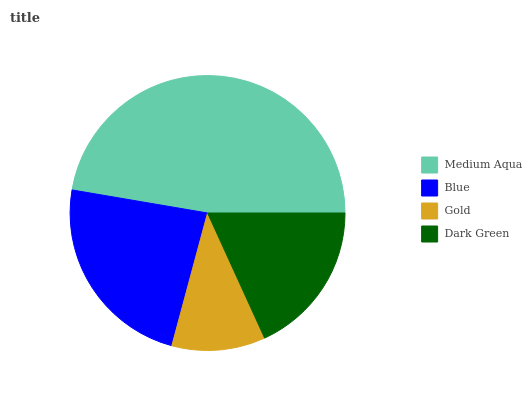Is Gold the minimum?
Answer yes or no. Yes. Is Medium Aqua the maximum?
Answer yes or no. Yes. Is Blue the minimum?
Answer yes or no. No. Is Blue the maximum?
Answer yes or no. No. Is Medium Aqua greater than Blue?
Answer yes or no. Yes. Is Blue less than Medium Aqua?
Answer yes or no. Yes. Is Blue greater than Medium Aqua?
Answer yes or no. No. Is Medium Aqua less than Blue?
Answer yes or no. No. Is Blue the high median?
Answer yes or no. Yes. Is Dark Green the low median?
Answer yes or no. Yes. Is Gold the high median?
Answer yes or no. No. Is Gold the low median?
Answer yes or no. No. 